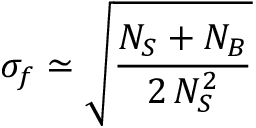<formula> <loc_0><loc_0><loc_500><loc_500>\sigma _ { f } \simeq \sqrt { \frac { N _ { S } + N _ { B } } { 2 \, N _ { S } ^ { 2 } } }</formula> 